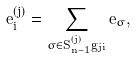Convert formula to latex. <formula><loc_0><loc_0><loc_500><loc_500>e _ { i } ^ { ( j ) } = \sum _ { \sigma \in S _ { n - 1 } ^ { ( j ) } g _ { j i } } e _ { \sigma } ,</formula> 